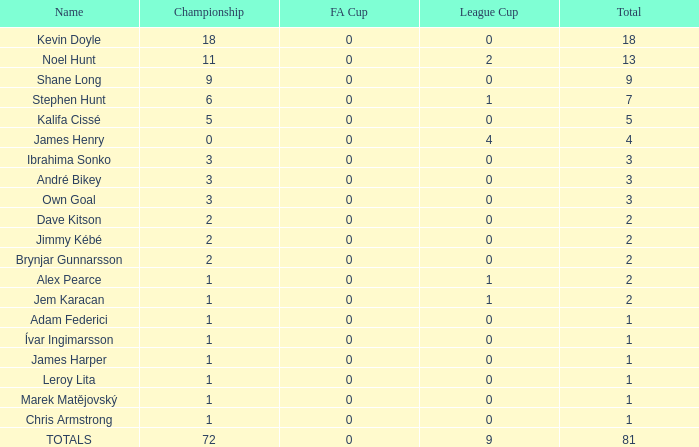How many total championships does james henry have with more than one league cup? 0.0. 